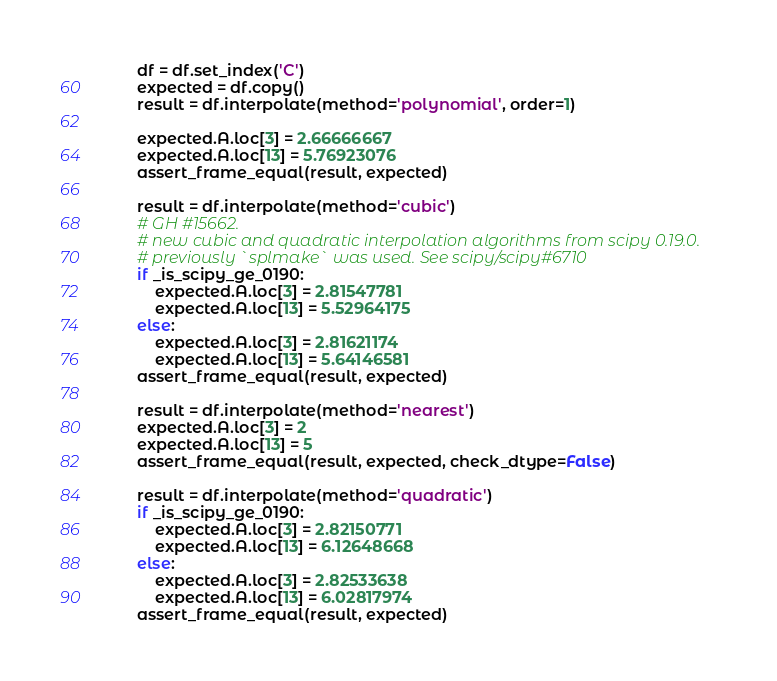Convert code to text. <code><loc_0><loc_0><loc_500><loc_500><_Python_>        df = df.set_index('C')
        expected = df.copy()
        result = df.interpolate(method='polynomial', order=1)

        expected.A.loc[3] = 2.66666667
        expected.A.loc[13] = 5.76923076
        assert_frame_equal(result, expected)

        result = df.interpolate(method='cubic')
        # GH #15662.
        # new cubic and quadratic interpolation algorithms from scipy 0.19.0.
        # previously `splmake` was used. See scipy/scipy#6710
        if _is_scipy_ge_0190:
            expected.A.loc[3] = 2.81547781
            expected.A.loc[13] = 5.52964175
        else:
            expected.A.loc[3] = 2.81621174
            expected.A.loc[13] = 5.64146581
        assert_frame_equal(result, expected)

        result = df.interpolate(method='nearest')
        expected.A.loc[3] = 2
        expected.A.loc[13] = 5
        assert_frame_equal(result, expected, check_dtype=False)

        result = df.interpolate(method='quadratic')
        if _is_scipy_ge_0190:
            expected.A.loc[3] = 2.82150771
            expected.A.loc[13] = 6.12648668
        else:
            expected.A.loc[3] = 2.82533638
            expected.A.loc[13] = 6.02817974
        assert_frame_equal(result, expected)
</code> 